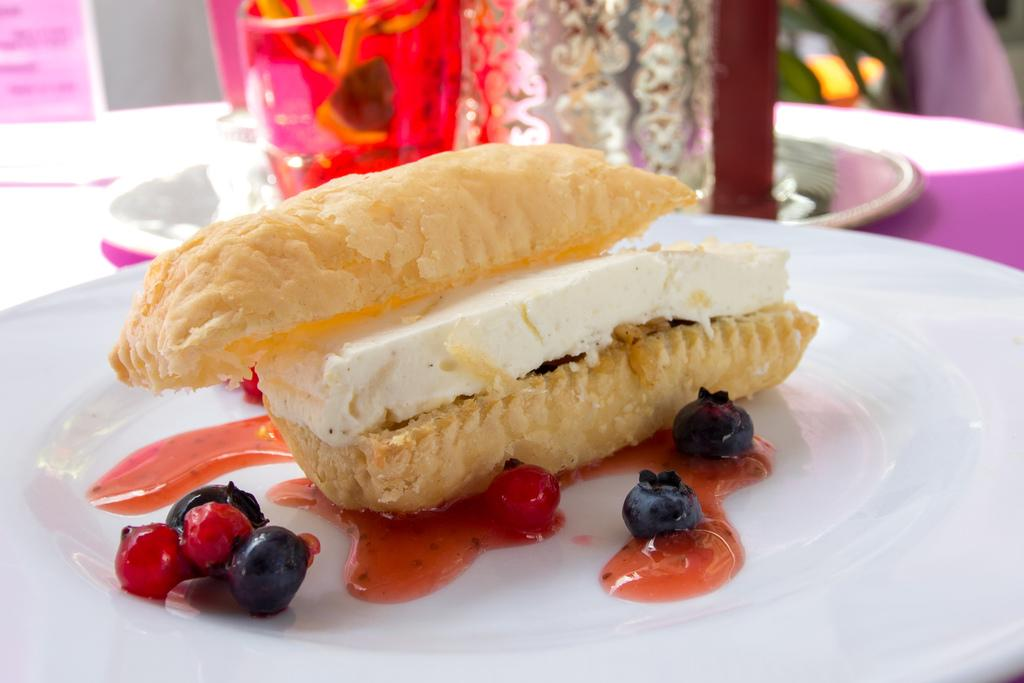What is on the white plate in the image? There are berries and red-colored paste on the white plate. What type of food item is on the white plate? There is a food item on the white plate, but the specific type is not mentioned in the facts. What color is the plate in the image? The plate in the image is white. How is the background of the image depicted? The background of the image is blurred. How many cherries are on the tin in the image? There is no tin or cherries present in the image. What type of shoes can be seen in the image? There are no shoes visible in the image. 